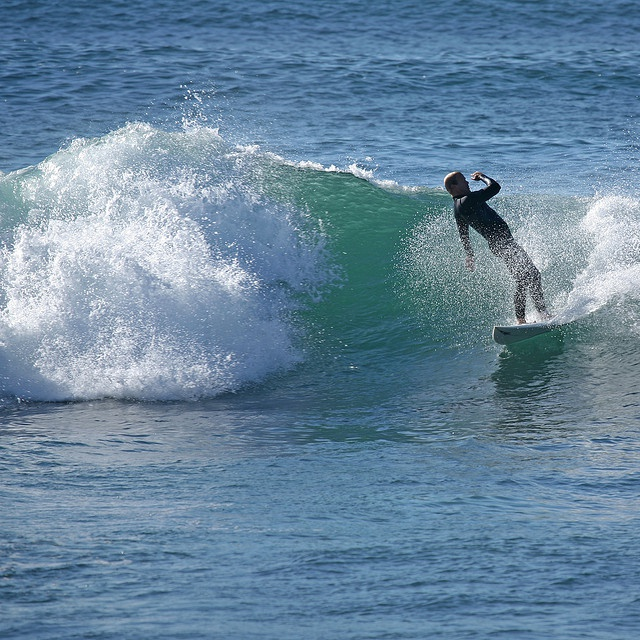Describe the objects in this image and their specific colors. I can see people in blue, black, gray, and darkgray tones and surfboard in blue, purple, black, darkblue, and gray tones in this image. 